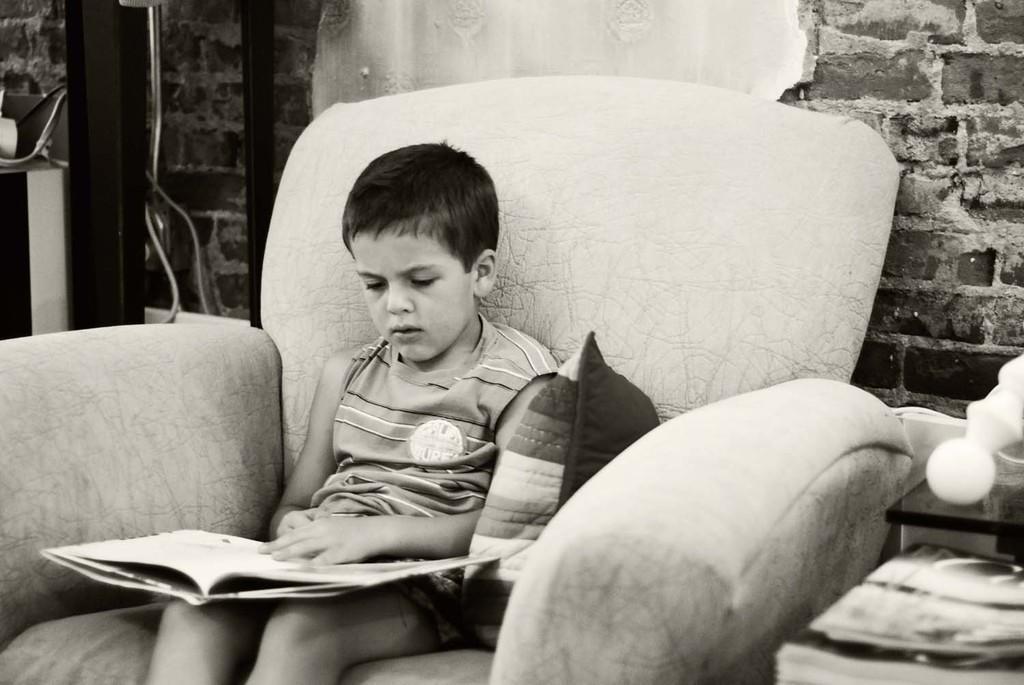In one or two sentences, can you explain what this image depicts? This is a black and white image. There is a sofa in the middle ,a child is sitting in that sofa. There is a pillow beside him. He is holding a book in his hand. There is a book in the bottom right corner, the wall is with bricks. 